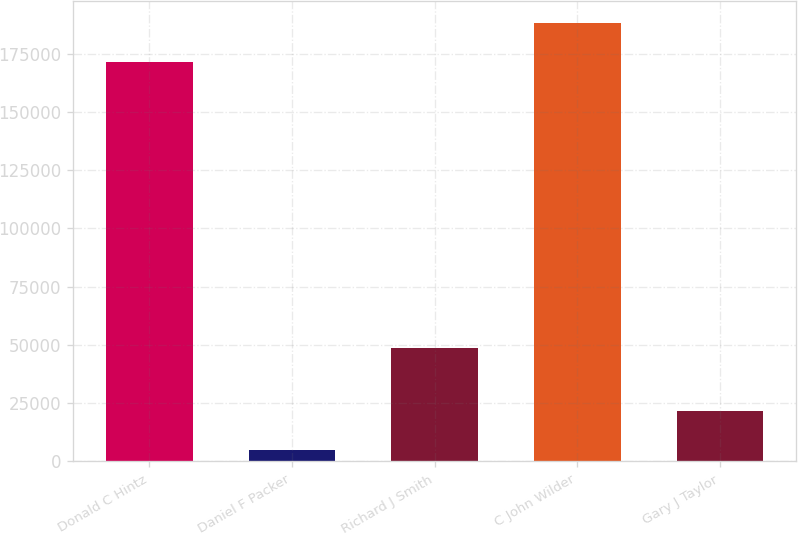<chart> <loc_0><loc_0><loc_500><loc_500><bar_chart><fcel>Donald C Hintz<fcel>Daniel F Packer<fcel>Richard J Smith<fcel>C John Wilder<fcel>Gary J Taylor<nl><fcel>171580<fcel>4727<fcel>48675<fcel>188344<fcel>21491.1<nl></chart> 